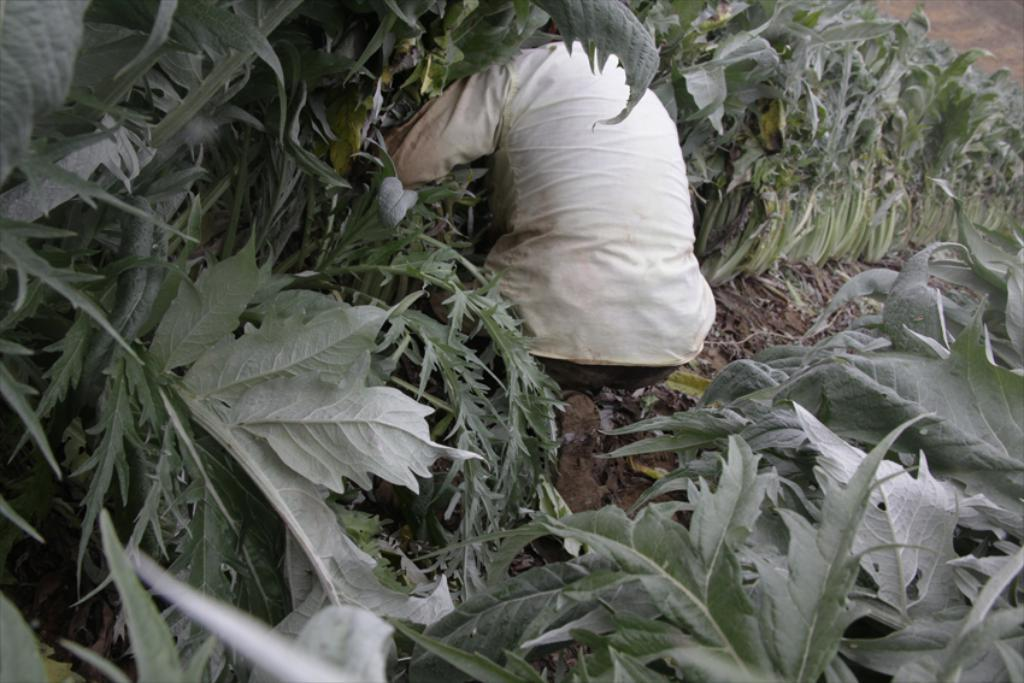What type of living organisms can be seen in the image? Plants can be seen in the image. Can you describe the person in the image? There is a person in the image, and they are wearing a cream shirt. What type of fire can be seen in the image? There is no fire present in the image. What is the person's opinion on the topic of climate change in the image? The image does not provide any information about the person's opinion on the topic of climate change. Is there a ring visible on the person's finger in the image? There is no ring visible on the person's finger in the image. 